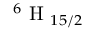<formula> <loc_0><loc_0><loc_500><loc_500>^ { 6 } H _ { 1 5 / 2 }</formula> 